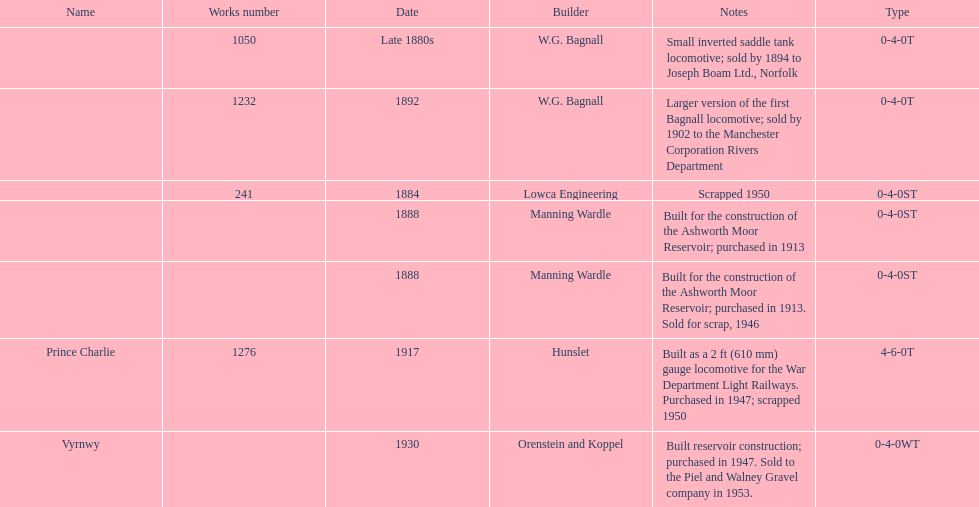How many locomotives were scrapped? 3. 